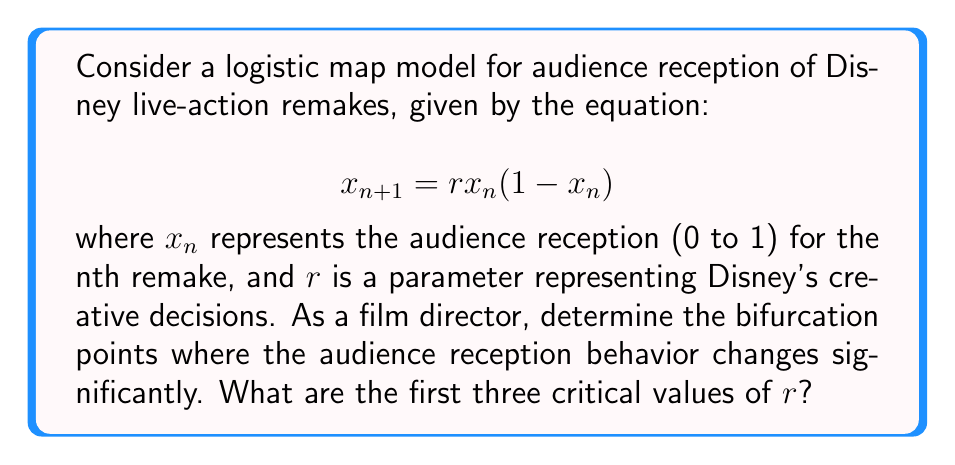Show me your answer to this math problem. To find the bifurcation points, we need to analyze the stability of the fixed points and their period-doubling bifurcations:

1. Find the fixed points:
   Set $x_{n+1} = x_n = x^*$
   $$x^* = rx^*(1-x^*)$$
   Solving this equation gives two fixed points:
   $$x^*_1 = 0 \text{ and } x^*_2 = 1 - \frac{1}{r}$$

2. Analyze stability of $x^*_1 = 0$:
   The derivative of the map at $x^*_1$ is:
   $$\left|\frac{df}{dx}\right|_{x=0} = |r|$$
   This fixed point loses stability when $|r| > 1$, so the first bifurcation occurs at $r_1 = 1$.

3. Analyze stability of $x^*_2 = 1 - \frac{1}{r}$:
   The derivative at this fixed point is:
   $$\left|\frac{df}{dx}\right|_{x=x^*_2} = |2-r|$$
   This fixed point loses stability when $|2-r| > 1$, so the second bifurcation occurs at $r_2 = 3$.

4. Period-doubling bifurcation:
   After $r = 3$, the system undergoes a series of period-doubling bifurcations. The first period-doubling occurs at approximately $r_3 = 3.45$.

These bifurcation points represent critical changes in audience reception patterns:
- $r_1 = 1$: Transition from extinction to stable reception
- $r_2 = 3$: Transition from stable to oscillating reception
- $r_3 \approx 3.45$: Beginning of more complex oscillations
Answer: $r_1 = 1$, $r_2 = 3$, $r_3 \approx 3.45$ 